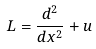<formula> <loc_0><loc_0><loc_500><loc_500>L = \frac { d ^ { 2 } } { d x ^ { 2 } } + u</formula> 